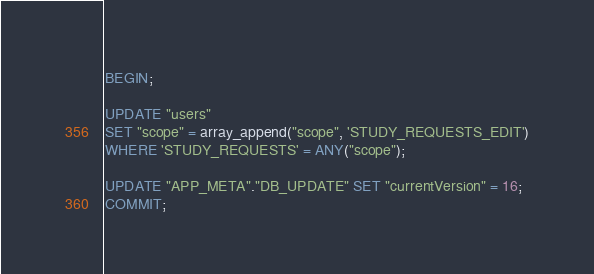<code> <loc_0><loc_0><loc_500><loc_500><_SQL_>BEGIN;

UPDATE "users"
SET "scope" = array_append("scope", 'STUDY_REQUESTS_EDIT')
WHERE 'STUDY_REQUESTS' = ANY("scope");

UPDATE "APP_META"."DB_UPDATE" SET "currentVersion" = 16;
COMMIT;
</code> 